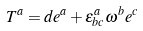Convert formula to latex. <formula><loc_0><loc_0><loc_500><loc_500>T ^ { a } = d e ^ { a } + \epsilon _ { b c } ^ { a } \omega ^ { b } e ^ { c }</formula> 